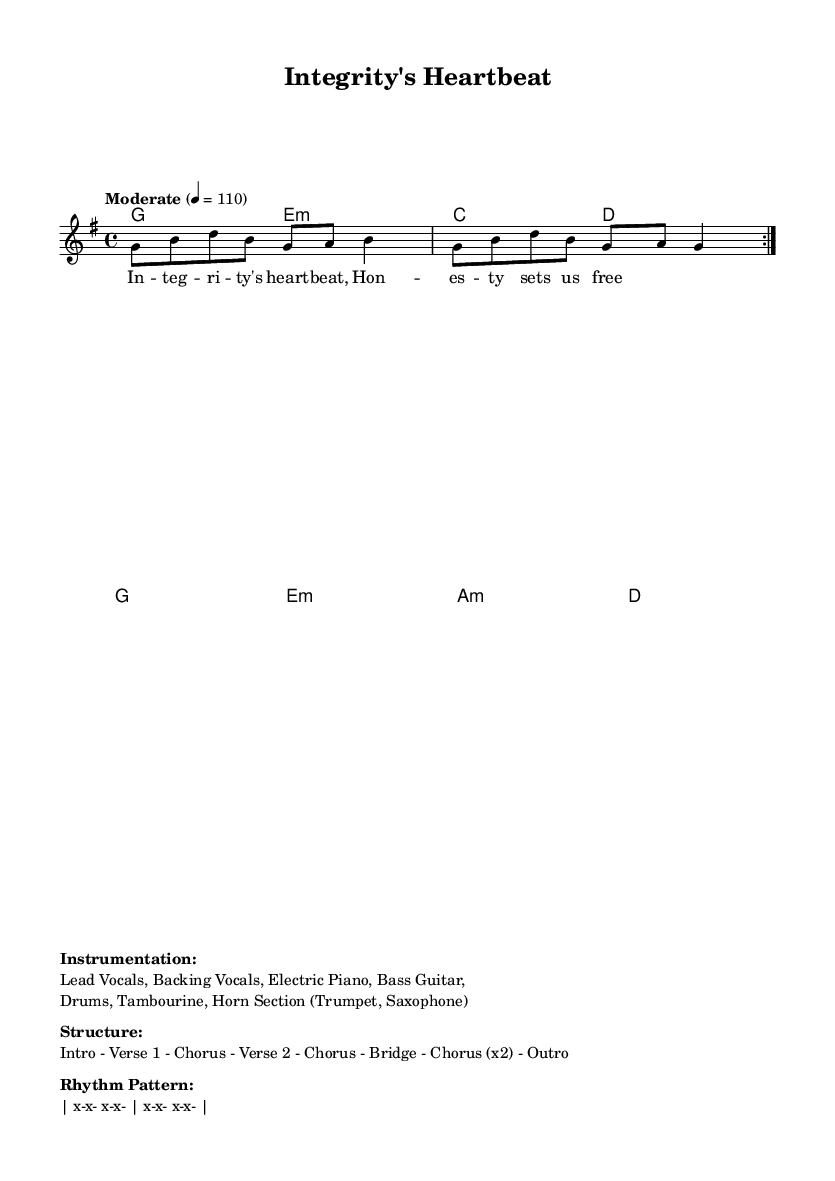What is the key signature of this music? The key signature is G major, which has one sharp (F#). This can be determined by looking at the beginning of the staff where the sharps are indicated.
Answer: G major What is the time signature of this music? The time signature is 4/4, which is provided at the beginning of the score next to the key signature. This means there are four beats in each measure.
Answer: 4/4 What is the tempo marking for this piece? The tempo marking is Moderate, specified above the staff with the equivalent of 110 beats per minute. This indicates a moderate pace for the performance.
Answer: Moderate How many verses are in the structure of the song? The structure indicates there are two verses, as it states "Verse 1" and "Verse 2," directly showing that it consists of two distinct verses.
Answer: 2 What instruments are included in the instrumentation? The instruments listed include Lead Vocals, Backing Vocals, Electric Piano, Bass Guitar, Drums, Tambourine, and Horn Section. These are all mentioned under the instrumentation section.
Answer: Lead Vocals, Backing Vocals, Electric Piano, Bass Guitar, Drums, Tambourine, Horn Section What is the function of the horn section in this soul piece? The horn section, typically consisting of musical instruments like trumpet and saxophone, generally adds richness and depth to the song, enhancing its melodic and harmonic complexity. Specifically, in soul music, they often add a distinctive sound that complements the vocals.
Answer: Complement vocals 